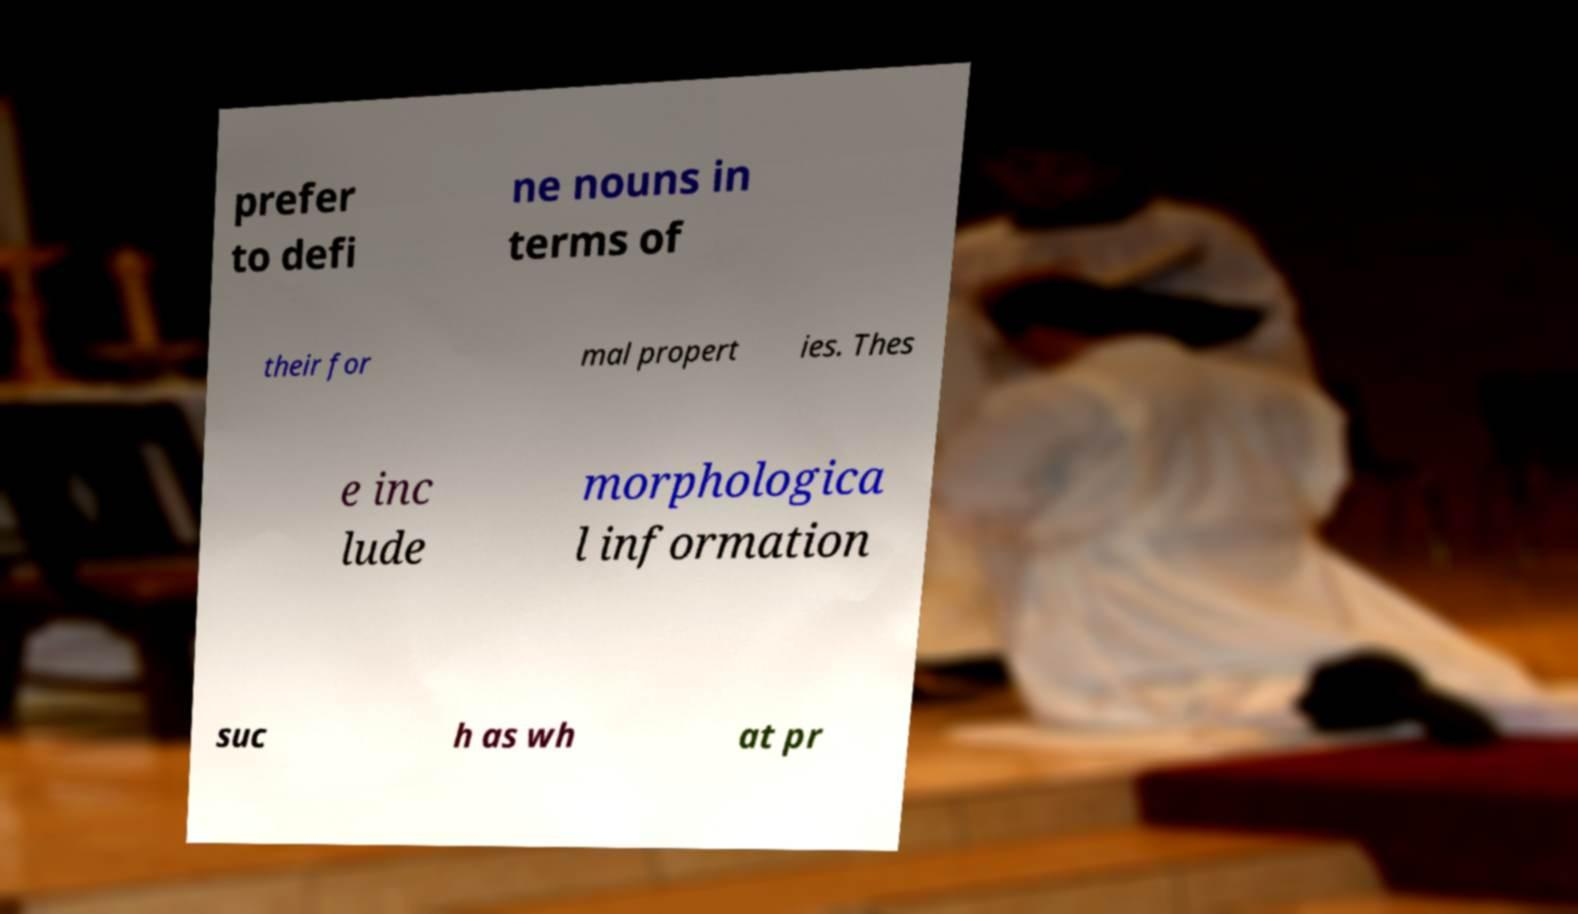Please identify and transcribe the text found in this image. prefer to defi ne nouns in terms of their for mal propert ies. Thes e inc lude morphologica l information suc h as wh at pr 